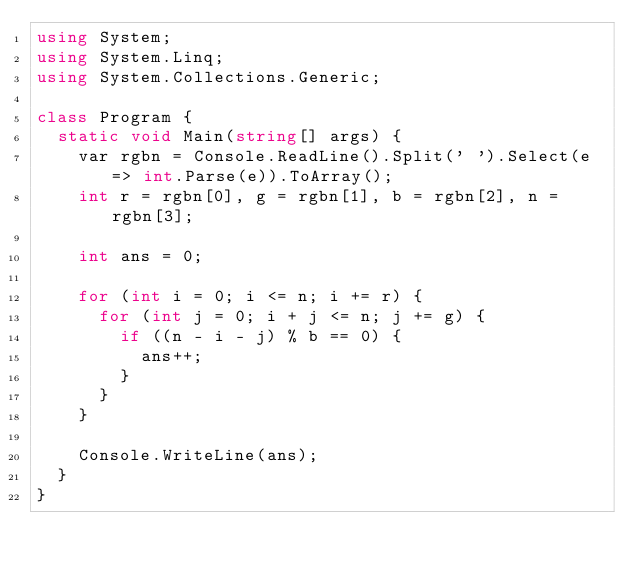Convert code to text. <code><loc_0><loc_0><loc_500><loc_500><_C#_>using System;
using System.Linq;
using System.Collections.Generic;

class Program {
  static void Main(string[] args) {
    var rgbn = Console.ReadLine().Split(' ').Select(e => int.Parse(e)).ToArray();
    int r = rgbn[0], g = rgbn[1], b = rgbn[2], n = rgbn[3];

    int ans = 0;

    for (int i = 0; i <= n; i += r) {
      for (int j = 0; i + j <= n; j += g) {
        if ((n - i - j) % b == 0) {
          ans++;
        }
      }
    }

    Console.WriteLine(ans);
  }
}
</code> 